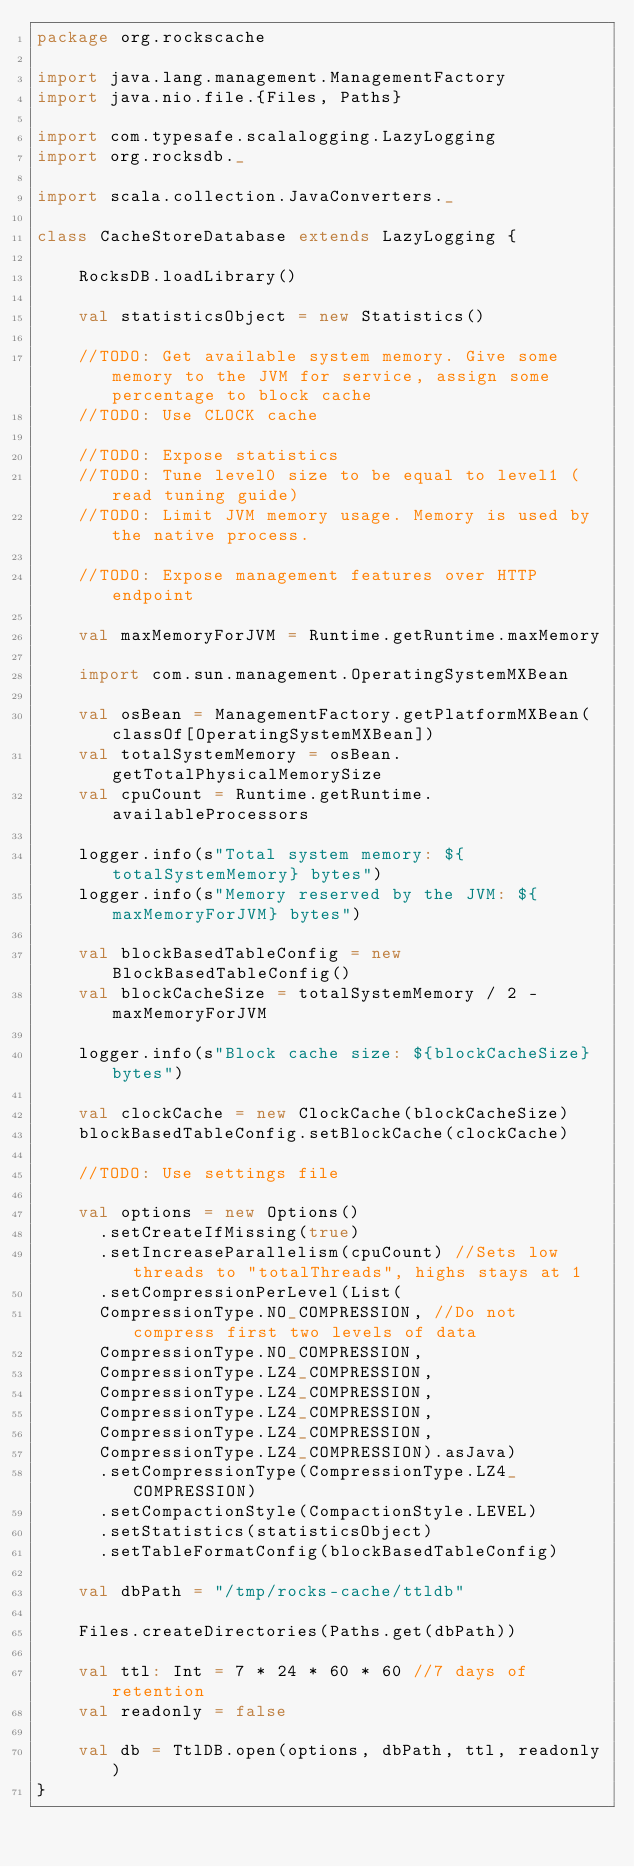Convert code to text. <code><loc_0><loc_0><loc_500><loc_500><_Scala_>package org.rockscache

import java.lang.management.ManagementFactory
import java.nio.file.{Files, Paths}

import com.typesafe.scalalogging.LazyLogging
import org.rocksdb._

import scala.collection.JavaConverters._

class CacheStoreDatabase extends LazyLogging {

    RocksDB.loadLibrary()

    val statisticsObject = new Statistics()

    //TODO: Get available system memory. Give some memory to the JVM for service, assign some percentage to block cache
    //TODO: Use CLOCK cache

    //TODO: Expose statistics
    //TODO: Tune level0 size to be equal to level1 (read tuning guide)
    //TODO: Limit JVM memory usage. Memory is used by the native process.

    //TODO: Expose management features over HTTP endpoint

    val maxMemoryForJVM = Runtime.getRuntime.maxMemory

    import com.sun.management.OperatingSystemMXBean

    val osBean = ManagementFactory.getPlatformMXBean(classOf[OperatingSystemMXBean])
    val totalSystemMemory = osBean.getTotalPhysicalMemorySize
    val cpuCount = Runtime.getRuntime.availableProcessors

    logger.info(s"Total system memory: ${totalSystemMemory} bytes")
    logger.info(s"Memory reserved by the JVM: ${maxMemoryForJVM} bytes")

    val blockBasedTableConfig = new BlockBasedTableConfig()
    val blockCacheSize = totalSystemMemory / 2 - maxMemoryForJVM

    logger.info(s"Block cache size: ${blockCacheSize} bytes")

    val clockCache = new ClockCache(blockCacheSize)
    blockBasedTableConfig.setBlockCache(clockCache)

    //TODO: Use settings file

    val options = new Options()
      .setCreateIfMissing(true)
      .setIncreaseParallelism(cpuCount) //Sets low threads to "totalThreads", highs stays at 1
      .setCompressionPerLevel(List(
      CompressionType.NO_COMPRESSION, //Do not compress first two levels of data
      CompressionType.NO_COMPRESSION,
      CompressionType.LZ4_COMPRESSION,
      CompressionType.LZ4_COMPRESSION,
      CompressionType.LZ4_COMPRESSION,
      CompressionType.LZ4_COMPRESSION,
      CompressionType.LZ4_COMPRESSION).asJava)
      .setCompressionType(CompressionType.LZ4_COMPRESSION)
      .setCompactionStyle(CompactionStyle.LEVEL)
      .setStatistics(statisticsObject)
      .setTableFormatConfig(blockBasedTableConfig)

    val dbPath = "/tmp/rocks-cache/ttldb"

    Files.createDirectories(Paths.get(dbPath))

    val ttl: Int = 7 * 24 * 60 * 60 //7 days of retention
    val readonly = false

    val db = TtlDB.open(options, dbPath, ttl, readonly)
}
</code> 